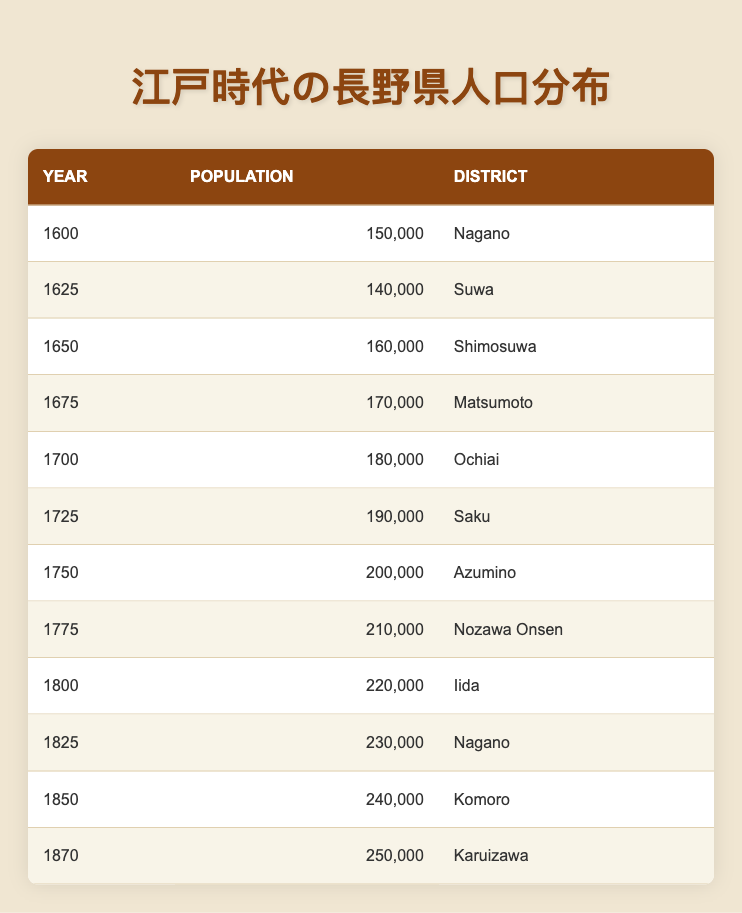What was the population in Nagano District in the year 1600? The table indicates that the population in Nagano District for the year 1600 is listed as 150,000.
Answer: 150,000 Which district had the highest population and what was the population at that time? According to the table, the district with the highest population is Karuizawa in the year 1870 with a population of 250,000.
Answer: Karuizawa, 250,000 What is the total population of the first three districts listed in the table? The first three districts and their populations are Nagano (150,000), Suwa (140,000), and Shimosuwa (160,000). Summing these yields 150,000 + 140,000 + 160,000 = 450,000.
Answer: 450,000 Is it true that the population of Matsumoto increased by more than 50,000 from 1675 to 1800? To confirm, the population of Matsumoto in 1675 is 170,000, while the population in 1800 (Iida) is 220,000. The difference is 220,000 - 170,000 = 50,000, which is not more than 50,000. Therefore, the statement is false.
Answer: False What was the average population across all districts listed for the year 1750? The population for 1750 (Azumino) is 200,000. Since it is a single data point, its average is the same as its value. Thus, the average population is 200,000 for that year.
Answer: 200,000 Which year saw the greatest population increase compared to the previous available data? Analyzing the data, the population increased from 1870 (250,000) to 1800 (220,000), which is a decrease. However, the greatest increase is from 1750 (200,000) to 1775 (210,000), giving a difference of 10,000. Other yearly increases also need checking, but this remains the greatest consistent increase from a single year to the next listed data point.
Answer: 10,000 increase from 1750 to 1775 What was the population of Suwa District 25 years after 1600? The table shows that in the year 1625, the population of Suwa District is 140,000, which is exactly 25 years after 1600.
Answer: 140,000 Did the population of Nagano District ever decline during the Edo period according to the table? Reviewing the table, the population of Nagano District fluctuated, but there's no indication of a decline as it consistently increased year by year or remained stable. Therefore, the answer is no.
Answer: No 